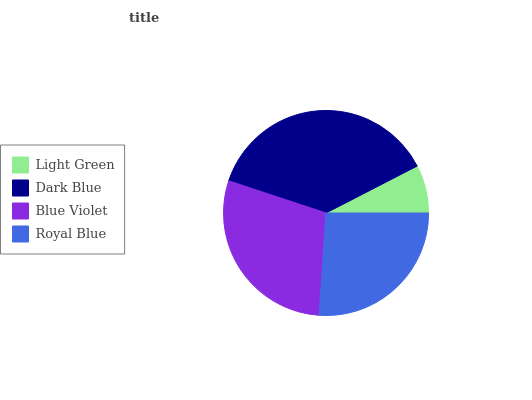Is Light Green the minimum?
Answer yes or no. Yes. Is Dark Blue the maximum?
Answer yes or no. Yes. Is Blue Violet the minimum?
Answer yes or no. No. Is Blue Violet the maximum?
Answer yes or no. No. Is Dark Blue greater than Blue Violet?
Answer yes or no. Yes. Is Blue Violet less than Dark Blue?
Answer yes or no. Yes. Is Blue Violet greater than Dark Blue?
Answer yes or no. No. Is Dark Blue less than Blue Violet?
Answer yes or no. No. Is Blue Violet the high median?
Answer yes or no. Yes. Is Royal Blue the low median?
Answer yes or no. Yes. Is Dark Blue the high median?
Answer yes or no. No. Is Blue Violet the low median?
Answer yes or no. No. 